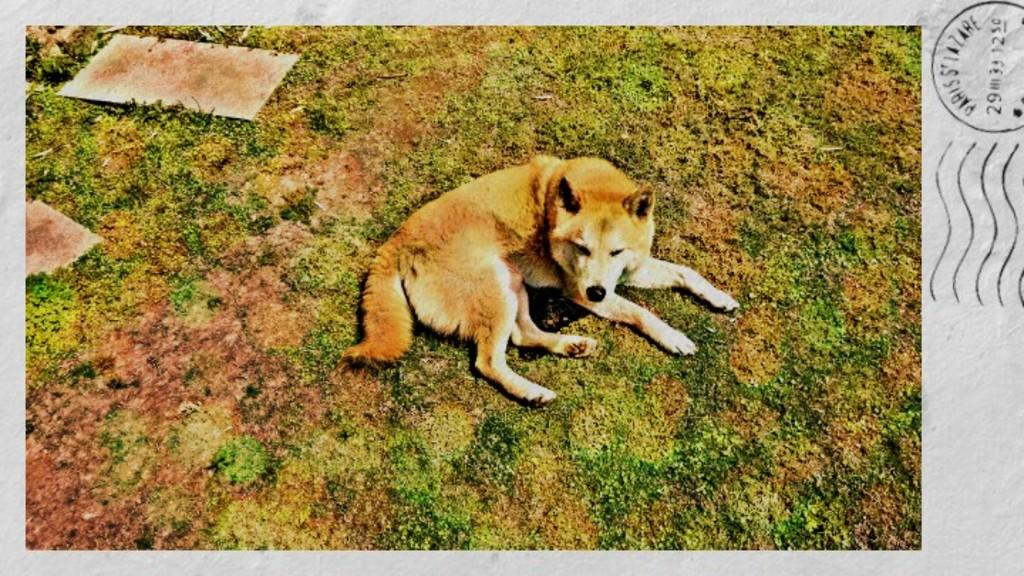What type of animal is on the ground in the image? There is a dog on the ground in the image. What can be seen on the right side of the image? There is text on the right side of the image. What type of terrain is visible in the image? There is grass visible in the image. What objects resemble marbles in the image? There are stones in the image that resemble marbles. How many people are resting with their pets in the image? There are no people or pets resting in the image; it only features a dog, text, grass, and stones. 